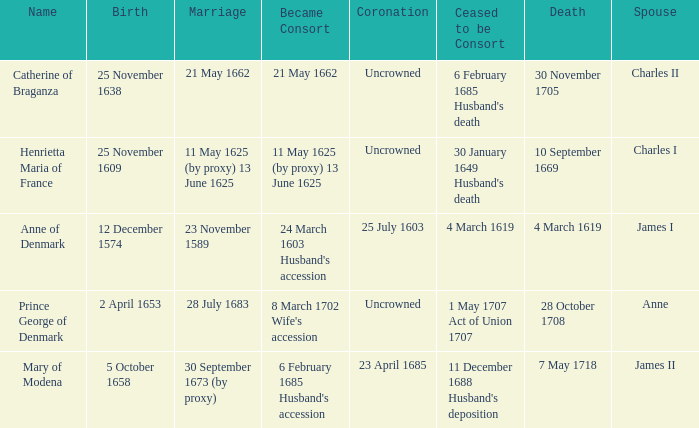On what date did James II take a consort? 6 February 1685 Husband's accession. 